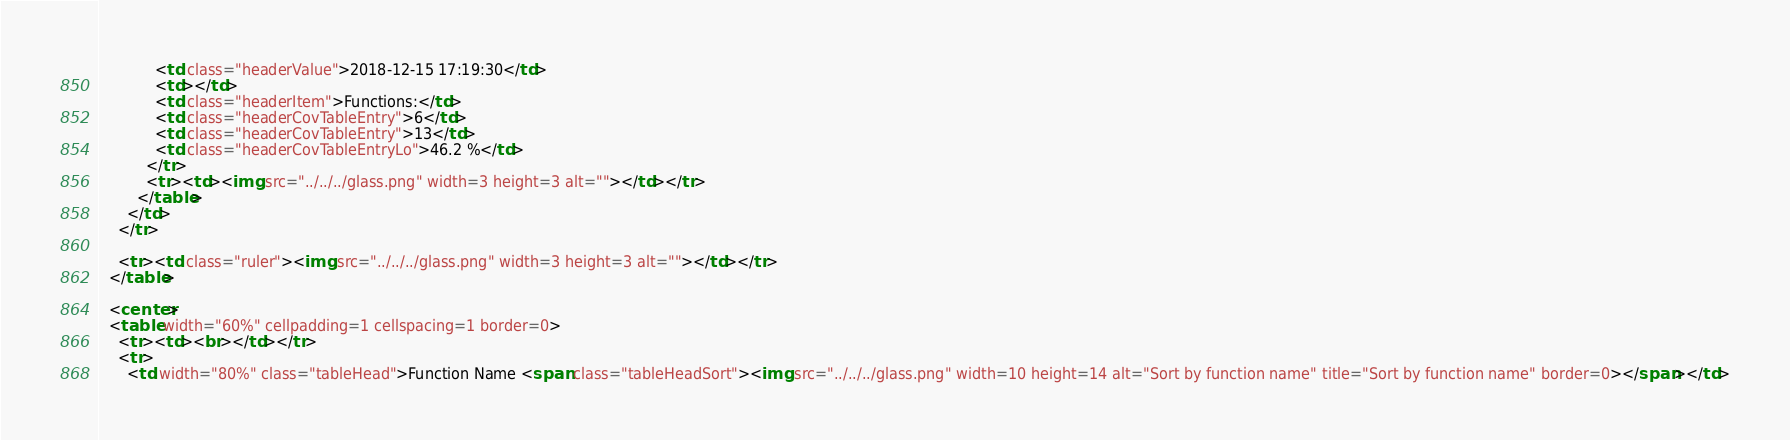Convert code to text. <code><loc_0><loc_0><loc_500><loc_500><_HTML_>            <td class="headerValue">2018-12-15 17:19:30</td>
            <td></td>
            <td class="headerItem">Functions:</td>
            <td class="headerCovTableEntry">6</td>
            <td class="headerCovTableEntry">13</td>
            <td class="headerCovTableEntryLo">46.2 %</td>
          </tr>
          <tr><td><img src="../../../glass.png" width=3 height=3 alt=""></td></tr>
        </table>
      </td>
    </tr>

    <tr><td class="ruler"><img src="../../../glass.png" width=3 height=3 alt=""></td></tr>
  </table>

  <center>
  <table width="60%" cellpadding=1 cellspacing=1 border=0>
    <tr><td><br></td></tr>
    <tr>
      <td width="80%" class="tableHead">Function Name <span class="tableHeadSort"><img src="../../../glass.png" width=10 height=14 alt="Sort by function name" title="Sort by function name" border=0></span></td></code> 